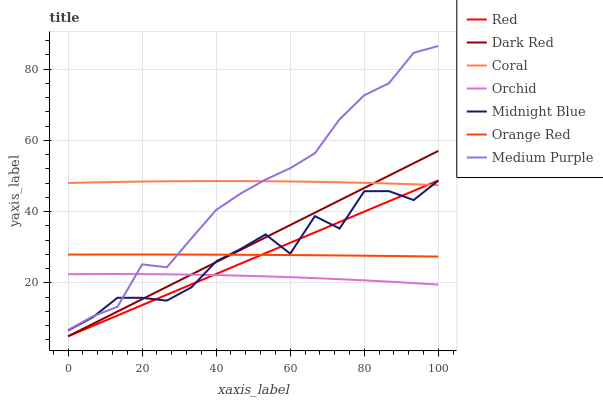Does Dark Red have the minimum area under the curve?
Answer yes or no. No. Does Dark Red have the maximum area under the curve?
Answer yes or no. No. Is Dark Red the smoothest?
Answer yes or no. No. Is Dark Red the roughest?
Answer yes or no. No. Does Coral have the lowest value?
Answer yes or no. No. Does Dark Red have the highest value?
Answer yes or no. No. Is Orchid less than Orange Red?
Answer yes or no. Yes. Is Medium Purple greater than Dark Red?
Answer yes or no. Yes. Does Orchid intersect Orange Red?
Answer yes or no. No. 